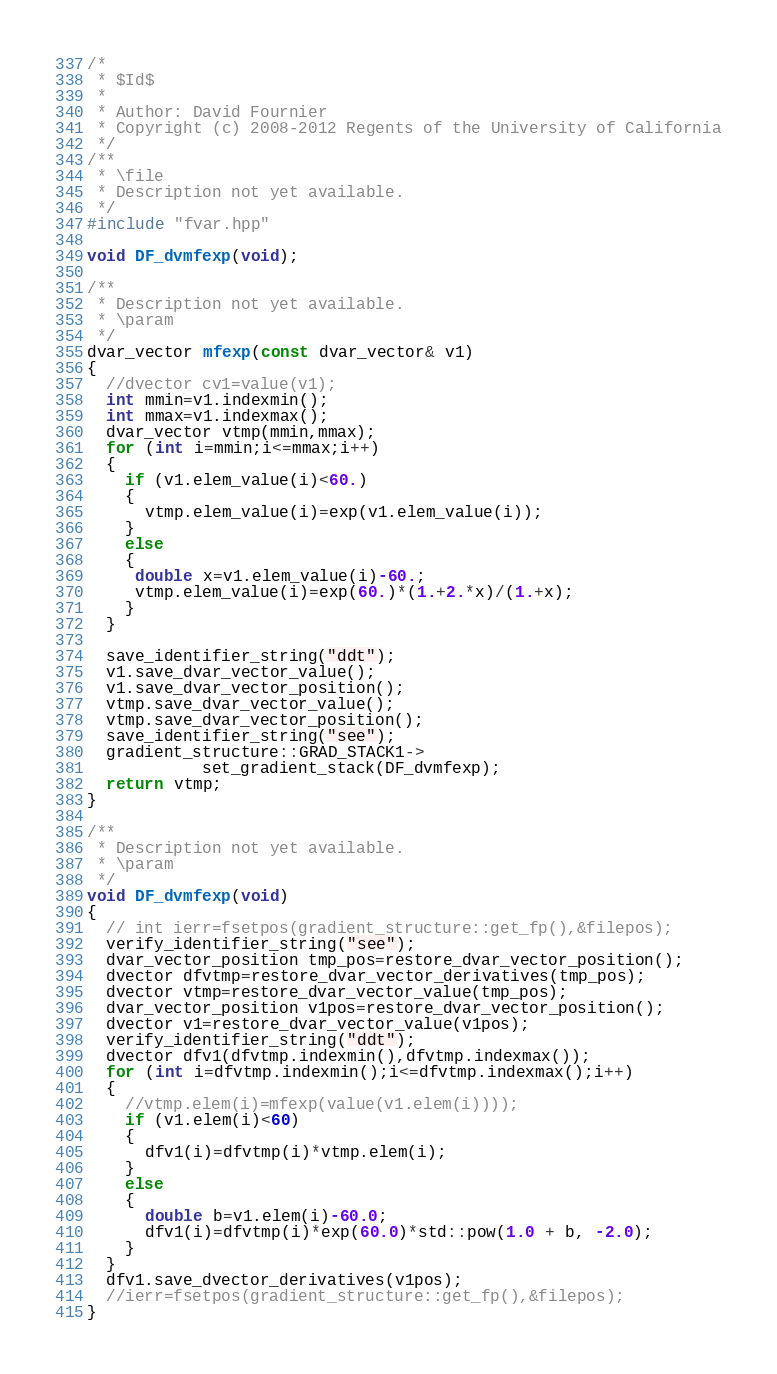<code> <loc_0><loc_0><loc_500><loc_500><_C++_>/*
 * $Id$
 *
 * Author: David Fournier
 * Copyright (c) 2008-2012 Regents of the University of California
 */
/**
 * \file
 * Description not yet available.
 */
#include "fvar.hpp"

void DF_dvmfexp(void);

/**
 * Description not yet available.
 * \param
 */
dvar_vector mfexp(const dvar_vector& v1)
{
  //dvector cv1=value(v1);
  int mmin=v1.indexmin();
  int mmax=v1.indexmax();
  dvar_vector vtmp(mmin,mmax);
  for (int i=mmin;i<=mmax;i++)
  {
    if (v1.elem_value(i)<60.)
    {
      vtmp.elem_value(i)=exp(v1.elem_value(i));
    }
    else
    {
     double x=v1.elem_value(i)-60.;
     vtmp.elem_value(i)=exp(60.)*(1.+2.*x)/(1.+x);
    }
  }

  save_identifier_string("ddt");
  v1.save_dvar_vector_value();
  v1.save_dvar_vector_position();
  vtmp.save_dvar_vector_value();
  vtmp.save_dvar_vector_position();
  save_identifier_string("see");
  gradient_structure::GRAD_STACK1->
            set_gradient_stack(DF_dvmfexp);
  return vtmp;
}

/**
 * Description not yet available.
 * \param
 */
void DF_dvmfexp(void)
{
  // int ierr=fsetpos(gradient_structure::get_fp(),&filepos);
  verify_identifier_string("see");
  dvar_vector_position tmp_pos=restore_dvar_vector_position();
  dvector dfvtmp=restore_dvar_vector_derivatives(tmp_pos);
  dvector vtmp=restore_dvar_vector_value(tmp_pos);
  dvar_vector_position v1pos=restore_dvar_vector_position();
  dvector v1=restore_dvar_vector_value(v1pos);
  verify_identifier_string("ddt");
  dvector dfv1(dfvtmp.indexmin(),dfvtmp.indexmax());
  for (int i=dfvtmp.indexmin();i<=dfvtmp.indexmax();i++)
  {
    //vtmp.elem(i)=mfexp(value(v1.elem(i))));
    if (v1.elem(i)<60)
    {
      dfv1(i)=dfvtmp(i)*vtmp.elem(i);
    }
    else
    {
      double b=v1.elem(i)-60.0;
      dfv1(i)=dfvtmp(i)*exp(60.0)*std::pow(1.0 + b, -2.0);
    }
  }
  dfv1.save_dvector_derivatives(v1pos);
  //ierr=fsetpos(gradient_structure::get_fp(),&filepos);
}
</code> 